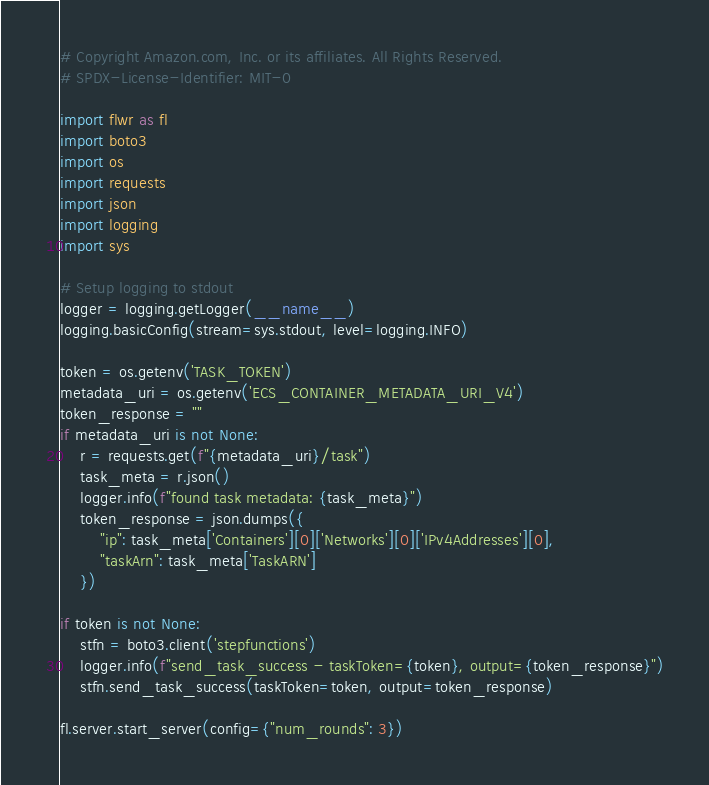Convert code to text. <code><loc_0><loc_0><loc_500><loc_500><_Python_># Copyright Amazon.com, Inc. or its affiliates. All Rights Reserved.
# SPDX-License-Identifier: MIT-0

import flwr as fl
import boto3
import os
import requests
import json
import logging
import sys

# Setup logging to stdout
logger = logging.getLogger(__name__)
logging.basicConfig(stream=sys.stdout, level=logging.INFO)

token = os.getenv('TASK_TOKEN')
metadata_uri = os.getenv('ECS_CONTAINER_METADATA_URI_V4')
token_response = ""
if metadata_uri is not None:
    r = requests.get(f"{metadata_uri}/task")
    task_meta = r.json()
    logger.info(f"found task metadata: {task_meta}")
    token_response = json.dumps({
        "ip": task_meta['Containers'][0]['Networks'][0]['IPv4Addresses'][0],
        "taskArn": task_meta['TaskARN']
    })

if token is not None:
    stfn = boto3.client('stepfunctions')
    logger.info(f"send_task_success - taskToken={token}, output={token_response}")
    stfn.send_task_success(taskToken=token, output=token_response)

fl.server.start_server(config={"num_rounds": 3})
</code> 